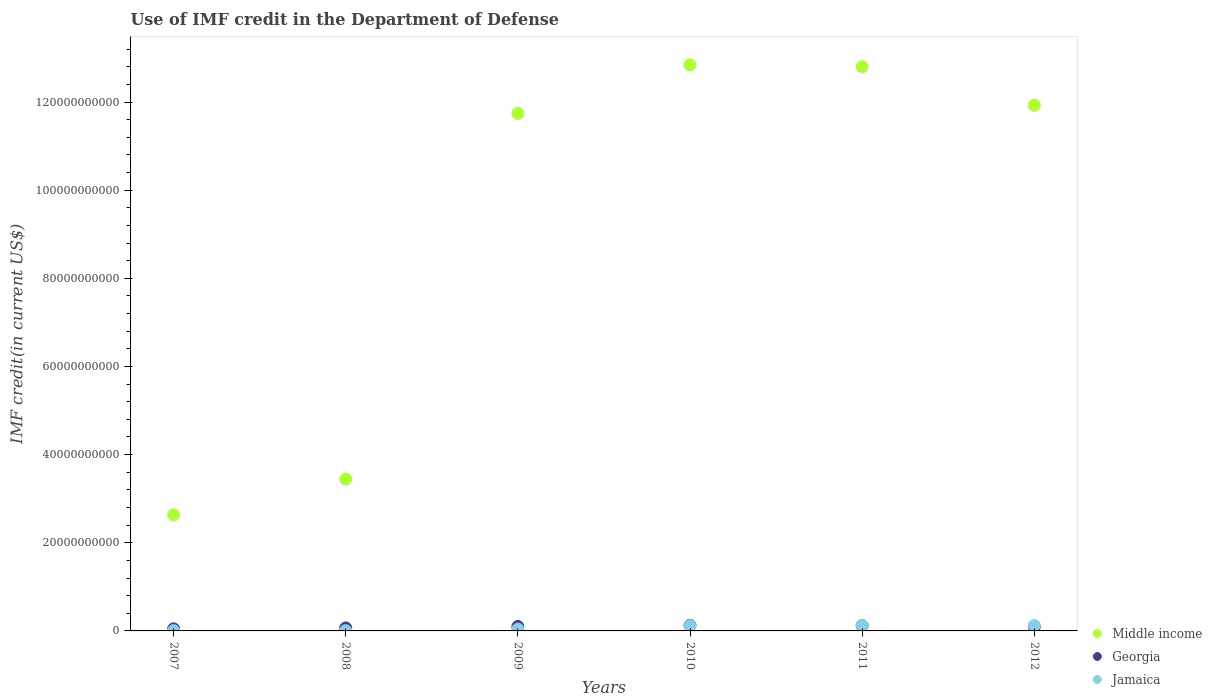What is the IMF credit in the Department of Defense in Middle income in 2009?
Provide a short and direct response. 1.17e+11. Across all years, what is the maximum IMF credit in the Department of Defense in Middle income?
Keep it short and to the point. 1.28e+11. Across all years, what is the minimum IMF credit in the Department of Defense in Jamaica?
Your answer should be very brief. 6.26e+07. In which year was the IMF credit in the Department of Defense in Middle income minimum?
Offer a very short reply. 2007. What is the total IMF credit in the Department of Defense in Jamaica in the graph?
Provide a succinct answer. 4.19e+09. What is the difference between the IMF credit in the Department of Defense in Georgia in 2010 and that in 2011?
Give a very brief answer. 6.24e+07. What is the difference between the IMF credit in the Department of Defense in Middle income in 2011 and the IMF credit in the Department of Defense in Jamaica in 2010?
Provide a succinct answer. 1.27e+11. What is the average IMF credit in the Department of Defense in Georgia per year?
Provide a short and direct response. 9.37e+08. In the year 2007, what is the difference between the IMF credit in the Department of Defense in Georgia and IMF credit in the Department of Defense in Jamaica?
Offer a terse response. 4.15e+08. In how many years, is the IMF credit in the Department of Defense in Jamaica greater than 8000000000 US$?
Your answer should be very brief. 0. What is the ratio of the IMF credit in the Department of Defense in Georgia in 2009 to that in 2012?
Provide a succinct answer. 1.05. Is the IMF credit in the Department of Defense in Georgia in 2010 less than that in 2012?
Provide a short and direct response. No. What is the difference between the highest and the second highest IMF credit in the Department of Defense in Jamaica?
Give a very brief answer. 1.32e+06. What is the difference between the highest and the lowest IMF credit in the Department of Defense in Jamaica?
Your answer should be compact. 1.17e+09. In how many years, is the IMF credit in the Department of Defense in Jamaica greater than the average IMF credit in the Department of Defense in Jamaica taken over all years?
Your answer should be compact. 3. Is the IMF credit in the Department of Defense in Jamaica strictly greater than the IMF credit in the Department of Defense in Georgia over the years?
Give a very brief answer. No. Is the IMF credit in the Department of Defense in Jamaica strictly less than the IMF credit in the Department of Defense in Middle income over the years?
Offer a very short reply. Yes. How many dotlines are there?
Provide a short and direct response. 3. Where does the legend appear in the graph?
Offer a very short reply. Bottom right. How many legend labels are there?
Give a very brief answer. 3. What is the title of the graph?
Ensure brevity in your answer.  Use of IMF credit in the Department of Defense. What is the label or title of the X-axis?
Offer a very short reply. Years. What is the label or title of the Y-axis?
Provide a short and direct response. IMF credit(in current US$). What is the IMF credit(in current US$) in Middle income in 2007?
Offer a terse response. 2.63e+1. What is the IMF credit(in current US$) of Georgia in 2007?
Keep it short and to the point. 4.79e+08. What is the IMF credit(in current US$) in Jamaica in 2007?
Provide a succinct answer. 6.42e+07. What is the IMF credit(in current US$) of Middle income in 2008?
Offer a very short reply. 3.44e+1. What is the IMF credit(in current US$) of Georgia in 2008?
Make the answer very short. 6.82e+08. What is the IMF credit(in current US$) in Jamaica in 2008?
Offer a very short reply. 6.26e+07. What is the IMF credit(in current US$) in Middle income in 2009?
Make the answer very short. 1.17e+11. What is the IMF credit(in current US$) in Georgia in 2009?
Give a very brief answer. 1.01e+09. What is the IMF credit(in current US$) in Jamaica in 2009?
Give a very brief answer. 4.10e+08. What is the IMF credit(in current US$) of Middle income in 2010?
Provide a succinct answer. 1.28e+11. What is the IMF credit(in current US$) of Georgia in 2010?
Offer a terse response. 1.27e+09. What is the IMF credit(in current US$) in Jamaica in 2010?
Your answer should be compact. 1.19e+09. What is the IMF credit(in current US$) in Middle income in 2011?
Your answer should be very brief. 1.28e+11. What is the IMF credit(in current US$) in Georgia in 2011?
Make the answer very short. 1.21e+09. What is the IMF credit(in current US$) of Jamaica in 2011?
Provide a short and direct response. 1.23e+09. What is the IMF credit(in current US$) of Middle income in 2012?
Offer a terse response. 1.19e+11. What is the IMF credit(in current US$) in Georgia in 2012?
Your response must be concise. 9.65e+08. What is the IMF credit(in current US$) of Jamaica in 2012?
Your answer should be very brief. 1.23e+09. Across all years, what is the maximum IMF credit(in current US$) of Middle income?
Your response must be concise. 1.28e+11. Across all years, what is the maximum IMF credit(in current US$) of Georgia?
Keep it short and to the point. 1.27e+09. Across all years, what is the maximum IMF credit(in current US$) in Jamaica?
Offer a terse response. 1.23e+09. Across all years, what is the minimum IMF credit(in current US$) of Middle income?
Give a very brief answer. 2.63e+1. Across all years, what is the minimum IMF credit(in current US$) of Georgia?
Make the answer very short. 4.79e+08. Across all years, what is the minimum IMF credit(in current US$) in Jamaica?
Offer a terse response. 6.26e+07. What is the total IMF credit(in current US$) of Middle income in the graph?
Make the answer very short. 5.54e+11. What is the total IMF credit(in current US$) in Georgia in the graph?
Ensure brevity in your answer.  5.62e+09. What is the total IMF credit(in current US$) of Jamaica in the graph?
Provide a short and direct response. 4.19e+09. What is the difference between the IMF credit(in current US$) of Middle income in 2007 and that in 2008?
Your response must be concise. -8.11e+09. What is the difference between the IMF credit(in current US$) of Georgia in 2007 and that in 2008?
Your answer should be very brief. -2.03e+08. What is the difference between the IMF credit(in current US$) of Jamaica in 2007 and that in 2008?
Offer a terse response. 1.62e+06. What is the difference between the IMF credit(in current US$) in Middle income in 2007 and that in 2009?
Provide a succinct answer. -9.11e+1. What is the difference between the IMF credit(in current US$) of Georgia in 2007 and that in 2009?
Give a very brief answer. -5.33e+08. What is the difference between the IMF credit(in current US$) in Jamaica in 2007 and that in 2009?
Offer a very short reply. -3.46e+08. What is the difference between the IMF credit(in current US$) of Middle income in 2007 and that in 2010?
Offer a terse response. -1.02e+11. What is the difference between the IMF credit(in current US$) of Georgia in 2007 and that in 2010?
Keep it short and to the point. -7.93e+08. What is the difference between the IMF credit(in current US$) in Jamaica in 2007 and that in 2010?
Keep it short and to the point. -1.12e+09. What is the difference between the IMF credit(in current US$) of Middle income in 2007 and that in 2011?
Make the answer very short. -1.02e+11. What is the difference between the IMF credit(in current US$) in Georgia in 2007 and that in 2011?
Ensure brevity in your answer.  -7.31e+08. What is the difference between the IMF credit(in current US$) in Jamaica in 2007 and that in 2011?
Keep it short and to the point. -1.17e+09. What is the difference between the IMF credit(in current US$) in Middle income in 2007 and that in 2012?
Offer a very short reply. -9.29e+1. What is the difference between the IMF credit(in current US$) of Georgia in 2007 and that in 2012?
Provide a short and direct response. -4.86e+08. What is the difference between the IMF credit(in current US$) in Jamaica in 2007 and that in 2012?
Offer a terse response. -1.17e+09. What is the difference between the IMF credit(in current US$) in Middle income in 2008 and that in 2009?
Offer a terse response. -8.29e+1. What is the difference between the IMF credit(in current US$) in Georgia in 2008 and that in 2009?
Provide a succinct answer. -3.30e+08. What is the difference between the IMF credit(in current US$) in Jamaica in 2008 and that in 2009?
Provide a succinct answer. -3.48e+08. What is the difference between the IMF credit(in current US$) in Middle income in 2008 and that in 2010?
Your answer should be compact. -9.40e+1. What is the difference between the IMF credit(in current US$) in Georgia in 2008 and that in 2010?
Make the answer very short. -5.90e+08. What is the difference between the IMF credit(in current US$) of Jamaica in 2008 and that in 2010?
Offer a terse response. -1.13e+09. What is the difference between the IMF credit(in current US$) of Middle income in 2008 and that in 2011?
Offer a very short reply. -9.36e+1. What is the difference between the IMF credit(in current US$) of Georgia in 2008 and that in 2011?
Your response must be concise. -5.28e+08. What is the difference between the IMF credit(in current US$) of Jamaica in 2008 and that in 2011?
Your answer should be compact. -1.17e+09. What is the difference between the IMF credit(in current US$) of Middle income in 2008 and that in 2012?
Your answer should be very brief. -8.48e+1. What is the difference between the IMF credit(in current US$) of Georgia in 2008 and that in 2012?
Provide a short and direct response. -2.83e+08. What is the difference between the IMF credit(in current US$) in Jamaica in 2008 and that in 2012?
Provide a short and direct response. -1.17e+09. What is the difference between the IMF credit(in current US$) in Middle income in 2009 and that in 2010?
Make the answer very short. -1.10e+1. What is the difference between the IMF credit(in current US$) of Georgia in 2009 and that in 2010?
Offer a terse response. -2.60e+08. What is the difference between the IMF credit(in current US$) of Jamaica in 2009 and that in 2010?
Ensure brevity in your answer.  -7.78e+08. What is the difference between the IMF credit(in current US$) of Middle income in 2009 and that in 2011?
Provide a succinct answer. -1.06e+1. What is the difference between the IMF credit(in current US$) in Georgia in 2009 and that in 2011?
Your answer should be compact. -1.98e+08. What is the difference between the IMF credit(in current US$) of Jamaica in 2009 and that in 2011?
Give a very brief answer. -8.23e+08. What is the difference between the IMF credit(in current US$) of Middle income in 2009 and that in 2012?
Give a very brief answer. -1.85e+09. What is the difference between the IMF credit(in current US$) of Georgia in 2009 and that in 2012?
Offer a very short reply. 4.68e+07. What is the difference between the IMF credit(in current US$) in Jamaica in 2009 and that in 2012?
Ensure brevity in your answer.  -8.25e+08. What is the difference between the IMF credit(in current US$) in Middle income in 2010 and that in 2011?
Your response must be concise. 4.26e+08. What is the difference between the IMF credit(in current US$) in Georgia in 2010 and that in 2011?
Your response must be concise. 6.24e+07. What is the difference between the IMF credit(in current US$) of Jamaica in 2010 and that in 2011?
Your answer should be compact. -4.53e+07. What is the difference between the IMF credit(in current US$) of Middle income in 2010 and that in 2012?
Make the answer very short. 9.18e+09. What is the difference between the IMF credit(in current US$) of Georgia in 2010 and that in 2012?
Your answer should be compact. 3.07e+08. What is the difference between the IMF credit(in current US$) in Jamaica in 2010 and that in 2012?
Provide a short and direct response. -4.66e+07. What is the difference between the IMF credit(in current US$) in Middle income in 2011 and that in 2012?
Make the answer very short. 8.76e+09. What is the difference between the IMF credit(in current US$) of Georgia in 2011 and that in 2012?
Your answer should be very brief. 2.44e+08. What is the difference between the IMF credit(in current US$) in Jamaica in 2011 and that in 2012?
Your response must be concise. -1.32e+06. What is the difference between the IMF credit(in current US$) in Middle income in 2007 and the IMF credit(in current US$) in Georgia in 2008?
Your answer should be very brief. 2.57e+1. What is the difference between the IMF credit(in current US$) of Middle income in 2007 and the IMF credit(in current US$) of Jamaica in 2008?
Your response must be concise. 2.63e+1. What is the difference between the IMF credit(in current US$) of Georgia in 2007 and the IMF credit(in current US$) of Jamaica in 2008?
Ensure brevity in your answer.  4.16e+08. What is the difference between the IMF credit(in current US$) of Middle income in 2007 and the IMF credit(in current US$) of Georgia in 2009?
Your answer should be compact. 2.53e+1. What is the difference between the IMF credit(in current US$) of Middle income in 2007 and the IMF credit(in current US$) of Jamaica in 2009?
Your answer should be very brief. 2.59e+1. What is the difference between the IMF credit(in current US$) of Georgia in 2007 and the IMF credit(in current US$) of Jamaica in 2009?
Make the answer very short. 6.88e+07. What is the difference between the IMF credit(in current US$) of Middle income in 2007 and the IMF credit(in current US$) of Georgia in 2010?
Keep it short and to the point. 2.51e+1. What is the difference between the IMF credit(in current US$) of Middle income in 2007 and the IMF credit(in current US$) of Jamaica in 2010?
Ensure brevity in your answer.  2.52e+1. What is the difference between the IMF credit(in current US$) in Georgia in 2007 and the IMF credit(in current US$) in Jamaica in 2010?
Keep it short and to the point. -7.09e+08. What is the difference between the IMF credit(in current US$) in Middle income in 2007 and the IMF credit(in current US$) in Georgia in 2011?
Make the answer very short. 2.51e+1. What is the difference between the IMF credit(in current US$) in Middle income in 2007 and the IMF credit(in current US$) in Jamaica in 2011?
Your response must be concise. 2.51e+1. What is the difference between the IMF credit(in current US$) in Georgia in 2007 and the IMF credit(in current US$) in Jamaica in 2011?
Offer a very short reply. -7.54e+08. What is the difference between the IMF credit(in current US$) of Middle income in 2007 and the IMF credit(in current US$) of Georgia in 2012?
Provide a short and direct response. 2.54e+1. What is the difference between the IMF credit(in current US$) of Middle income in 2007 and the IMF credit(in current US$) of Jamaica in 2012?
Your answer should be compact. 2.51e+1. What is the difference between the IMF credit(in current US$) in Georgia in 2007 and the IMF credit(in current US$) in Jamaica in 2012?
Your answer should be compact. -7.56e+08. What is the difference between the IMF credit(in current US$) of Middle income in 2008 and the IMF credit(in current US$) of Georgia in 2009?
Offer a very short reply. 3.34e+1. What is the difference between the IMF credit(in current US$) in Middle income in 2008 and the IMF credit(in current US$) in Jamaica in 2009?
Provide a short and direct response. 3.40e+1. What is the difference between the IMF credit(in current US$) of Georgia in 2008 and the IMF credit(in current US$) of Jamaica in 2009?
Your response must be concise. 2.72e+08. What is the difference between the IMF credit(in current US$) in Middle income in 2008 and the IMF credit(in current US$) in Georgia in 2010?
Ensure brevity in your answer.  3.32e+1. What is the difference between the IMF credit(in current US$) of Middle income in 2008 and the IMF credit(in current US$) of Jamaica in 2010?
Make the answer very short. 3.33e+1. What is the difference between the IMF credit(in current US$) of Georgia in 2008 and the IMF credit(in current US$) of Jamaica in 2010?
Offer a terse response. -5.06e+08. What is the difference between the IMF credit(in current US$) in Middle income in 2008 and the IMF credit(in current US$) in Georgia in 2011?
Give a very brief answer. 3.32e+1. What is the difference between the IMF credit(in current US$) of Middle income in 2008 and the IMF credit(in current US$) of Jamaica in 2011?
Provide a short and direct response. 3.32e+1. What is the difference between the IMF credit(in current US$) in Georgia in 2008 and the IMF credit(in current US$) in Jamaica in 2011?
Offer a terse response. -5.52e+08. What is the difference between the IMF credit(in current US$) of Middle income in 2008 and the IMF credit(in current US$) of Georgia in 2012?
Your response must be concise. 3.35e+1. What is the difference between the IMF credit(in current US$) of Middle income in 2008 and the IMF credit(in current US$) of Jamaica in 2012?
Make the answer very short. 3.32e+1. What is the difference between the IMF credit(in current US$) in Georgia in 2008 and the IMF credit(in current US$) in Jamaica in 2012?
Your response must be concise. -5.53e+08. What is the difference between the IMF credit(in current US$) in Middle income in 2009 and the IMF credit(in current US$) in Georgia in 2010?
Your response must be concise. 1.16e+11. What is the difference between the IMF credit(in current US$) of Middle income in 2009 and the IMF credit(in current US$) of Jamaica in 2010?
Ensure brevity in your answer.  1.16e+11. What is the difference between the IMF credit(in current US$) in Georgia in 2009 and the IMF credit(in current US$) in Jamaica in 2010?
Provide a succinct answer. -1.76e+08. What is the difference between the IMF credit(in current US$) of Middle income in 2009 and the IMF credit(in current US$) of Georgia in 2011?
Your answer should be compact. 1.16e+11. What is the difference between the IMF credit(in current US$) in Middle income in 2009 and the IMF credit(in current US$) in Jamaica in 2011?
Make the answer very short. 1.16e+11. What is the difference between the IMF credit(in current US$) of Georgia in 2009 and the IMF credit(in current US$) of Jamaica in 2011?
Give a very brief answer. -2.21e+08. What is the difference between the IMF credit(in current US$) of Middle income in 2009 and the IMF credit(in current US$) of Georgia in 2012?
Make the answer very short. 1.16e+11. What is the difference between the IMF credit(in current US$) of Middle income in 2009 and the IMF credit(in current US$) of Jamaica in 2012?
Make the answer very short. 1.16e+11. What is the difference between the IMF credit(in current US$) in Georgia in 2009 and the IMF credit(in current US$) in Jamaica in 2012?
Your answer should be compact. -2.23e+08. What is the difference between the IMF credit(in current US$) in Middle income in 2010 and the IMF credit(in current US$) in Georgia in 2011?
Provide a short and direct response. 1.27e+11. What is the difference between the IMF credit(in current US$) in Middle income in 2010 and the IMF credit(in current US$) in Jamaica in 2011?
Offer a terse response. 1.27e+11. What is the difference between the IMF credit(in current US$) in Georgia in 2010 and the IMF credit(in current US$) in Jamaica in 2011?
Offer a terse response. 3.87e+07. What is the difference between the IMF credit(in current US$) of Middle income in 2010 and the IMF credit(in current US$) of Georgia in 2012?
Make the answer very short. 1.27e+11. What is the difference between the IMF credit(in current US$) in Middle income in 2010 and the IMF credit(in current US$) in Jamaica in 2012?
Offer a terse response. 1.27e+11. What is the difference between the IMF credit(in current US$) in Georgia in 2010 and the IMF credit(in current US$) in Jamaica in 2012?
Make the answer very short. 3.73e+07. What is the difference between the IMF credit(in current US$) in Middle income in 2011 and the IMF credit(in current US$) in Georgia in 2012?
Offer a very short reply. 1.27e+11. What is the difference between the IMF credit(in current US$) of Middle income in 2011 and the IMF credit(in current US$) of Jamaica in 2012?
Make the answer very short. 1.27e+11. What is the difference between the IMF credit(in current US$) of Georgia in 2011 and the IMF credit(in current US$) of Jamaica in 2012?
Your answer should be very brief. -2.51e+07. What is the average IMF credit(in current US$) of Middle income per year?
Provide a succinct answer. 9.23e+1. What is the average IMF credit(in current US$) in Georgia per year?
Offer a terse response. 9.37e+08. What is the average IMF credit(in current US$) in Jamaica per year?
Give a very brief answer. 6.99e+08. In the year 2007, what is the difference between the IMF credit(in current US$) of Middle income and IMF credit(in current US$) of Georgia?
Your answer should be compact. 2.59e+1. In the year 2007, what is the difference between the IMF credit(in current US$) in Middle income and IMF credit(in current US$) in Jamaica?
Provide a short and direct response. 2.63e+1. In the year 2007, what is the difference between the IMF credit(in current US$) in Georgia and IMF credit(in current US$) in Jamaica?
Make the answer very short. 4.15e+08. In the year 2008, what is the difference between the IMF credit(in current US$) in Middle income and IMF credit(in current US$) in Georgia?
Ensure brevity in your answer.  3.38e+1. In the year 2008, what is the difference between the IMF credit(in current US$) in Middle income and IMF credit(in current US$) in Jamaica?
Give a very brief answer. 3.44e+1. In the year 2008, what is the difference between the IMF credit(in current US$) in Georgia and IMF credit(in current US$) in Jamaica?
Keep it short and to the point. 6.19e+08. In the year 2009, what is the difference between the IMF credit(in current US$) in Middle income and IMF credit(in current US$) in Georgia?
Your answer should be very brief. 1.16e+11. In the year 2009, what is the difference between the IMF credit(in current US$) in Middle income and IMF credit(in current US$) in Jamaica?
Your answer should be compact. 1.17e+11. In the year 2009, what is the difference between the IMF credit(in current US$) in Georgia and IMF credit(in current US$) in Jamaica?
Offer a very short reply. 6.02e+08. In the year 2010, what is the difference between the IMF credit(in current US$) in Middle income and IMF credit(in current US$) in Georgia?
Provide a short and direct response. 1.27e+11. In the year 2010, what is the difference between the IMF credit(in current US$) of Middle income and IMF credit(in current US$) of Jamaica?
Keep it short and to the point. 1.27e+11. In the year 2010, what is the difference between the IMF credit(in current US$) of Georgia and IMF credit(in current US$) of Jamaica?
Give a very brief answer. 8.40e+07. In the year 2011, what is the difference between the IMF credit(in current US$) in Middle income and IMF credit(in current US$) in Georgia?
Your response must be concise. 1.27e+11. In the year 2011, what is the difference between the IMF credit(in current US$) in Middle income and IMF credit(in current US$) in Jamaica?
Your response must be concise. 1.27e+11. In the year 2011, what is the difference between the IMF credit(in current US$) in Georgia and IMF credit(in current US$) in Jamaica?
Your response must be concise. -2.38e+07. In the year 2012, what is the difference between the IMF credit(in current US$) of Middle income and IMF credit(in current US$) of Georgia?
Provide a succinct answer. 1.18e+11. In the year 2012, what is the difference between the IMF credit(in current US$) of Middle income and IMF credit(in current US$) of Jamaica?
Keep it short and to the point. 1.18e+11. In the year 2012, what is the difference between the IMF credit(in current US$) in Georgia and IMF credit(in current US$) in Jamaica?
Provide a short and direct response. -2.70e+08. What is the ratio of the IMF credit(in current US$) in Middle income in 2007 to that in 2008?
Make the answer very short. 0.76. What is the ratio of the IMF credit(in current US$) of Georgia in 2007 to that in 2008?
Give a very brief answer. 0.7. What is the ratio of the IMF credit(in current US$) of Jamaica in 2007 to that in 2008?
Ensure brevity in your answer.  1.03. What is the ratio of the IMF credit(in current US$) in Middle income in 2007 to that in 2009?
Keep it short and to the point. 0.22. What is the ratio of the IMF credit(in current US$) in Georgia in 2007 to that in 2009?
Keep it short and to the point. 0.47. What is the ratio of the IMF credit(in current US$) in Jamaica in 2007 to that in 2009?
Keep it short and to the point. 0.16. What is the ratio of the IMF credit(in current US$) in Middle income in 2007 to that in 2010?
Offer a very short reply. 0.21. What is the ratio of the IMF credit(in current US$) in Georgia in 2007 to that in 2010?
Make the answer very short. 0.38. What is the ratio of the IMF credit(in current US$) in Jamaica in 2007 to that in 2010?
Ensure brevity in your answer.  0.05. What is the ratio of the IMF credit(in current US$) in Middle income in 2007 to that in 2011?
Ensure brevity in your answer.  0.21. What is the ratio of the IMF credit(in current US$) in Georgia in 2007 to that in 2011?
Give a very brief answer. 0.4. What is the ratio of the IMF credit(in current US$) of Jamaica in 2007 to that in 2011?
Provide a succinct answer. 0.05. What is the ratio of the IMF credit(in current US$) of Middle income in 2007 to that in 2012?
Your answer should be compact. 0.22. What is the ratio of the IMF credit(in current US$) of Georgia in 2007 to that in 2012?
Give a very brief answer. 0.5. What is the ratio of the IMF credit(in current US$) in Jamaica in 2007 to that in 2012?
Offer a very short reply. 0.05. What is the ratio of the IMF credit(in current US$) of Middle income in 2008 to that in 2009?
Your answer should be compact. 0.29. What is the ratio of the IMF credit(in current US$) of Georgia in 2008 to that in 2009?
Offer a very short reply. 0.67. What is the ratio of the IMF credit(in current US$) of Jamaica in 2008 to that in 2009?
Give a very brief answer. 0.15. What is the ratio of the IMF credit(in current US$) in Middle income in 2008 to that in 2010?
Keep it short and to the point. 0.27. What is the ratio of the IMF credit(in current US$) of Georgia in 2008 to that in 2010?
Make the answer very short. 0.54. What is the ratio of the IMF credit(in current US$) in Jamaica in 2008 to that in 2010?
Offer a very short reply. 0.05. What is the ratio of the IMF credit(in current US$) in Middle income in 2008 to that in 2011?
Give a very brief answer. 0.27. What is the ratio of the IMF credit(in current US$) in Georgia in 2008 to that in 2011?
Your answer should be very brief. 0.56. What is the ratio of the IMF credit(in current US$) of Jamaica in 2008 to that in 2011?
Your answer should be compact. 0.05. What is the ratio of the IMF credit(in current US$) in Middle income in 2008 to that in 2012?
Give a very brief answer. 0.29. What is the ratio of the IMF credit(in current US$) of Georgia in 2008 to that in 2012?
Your answer should be compact. 0.71. What is the ratio of the IMF credit(in current US$) in Jamaica in 2008 to that in 2012?
Keep it short and to the point. 0.05. What is the ratio of the IMF credit(in current US$) of Middle income in 2009 to that in 2010?
Offer a very short reply. 0.91. What is the ratio of the IMF credit(in current US$) of Georgia in 2009 to that in 2010?
Provide a succinct answer. 0.8. What is the ratio of the IMF credit(in current US$) in Jamaica in 2009 to that in 2010?
Give a very brief answer. 0.35. What is the ratio of the IMF credit(in current US$) in Middle income in 2009 to that in 2011?
Offer a very short reply. 0.92. What is the ratio of the IMF credit(in current US$) in Georgia in 2009 to that in 2011?
Ensure brevity in your answer.  0.84. What is the ratio of the IMF credit(in current US$) of Jamaica in 2009 to that in 2011?
Ensure brevity in your answer.  0.33. What is the ratio of the IMF credit(in current US$) in Middle income in 2009 to that in 2012?
Provide a succinct answer. 0.98. What is the ratio of the IMF credit(in current US$) of Georgia in 2009 to that in 2012?
Offer a terse response. 1.05. What is the ratio of the IMF credit(in current US$) of Jamaica in 2009 to that in 2012?
Your answer should be very brief. 0.33. What is the ratio of the IMF credit(in current US$) of Middle income in 2010 to that in 2011?
Make the answer very short. 1. What is the ratio of the IMF credit(in current US$) in Georgia in 2010 to that in 2011?
Provide a succinct answer. 1.05. What is the ratio of the IMF credit(in current US$) in Jamaica in 2010 to that in 2011?
Give a very brief answer. 0.96. What is the ratio of the IMF credit(in current US$) of Middle income in 2010 to that in 2012?
Offer a terse response. 1.08. What is the ratio of the IMF credit(in current US$) in Georgia in 2010 to that in 2012?
Offer a terse response. 1.32. What is the ratio of the IMF credit(in current US$) in Jamaica in 2010 to that in 2012?
Offer a terse response. 0.96. What is the ratio of the IMF credit(in current US$) in Middle income in 2011 to that in 2012?
Provide a short and direct response. 1.07. What is the ratio of the IMF credit(in current US$) in Georgia in 2011 to that in 2012?
Ensure brevity in your answer.  1.25. What is the difference between the highest and the second highest IMF credit(in current US$) in Middle income?
Your answer should be compact. 4.26e+08. What is the difference between the highest and the second highest IMF credit(in current US$) in Georgia?
Make the answer very short. 6.24e+07. What is the difference between the highest and the second highest IMF credit(in current US$) in Jamaica?
Provide a short and direct response. 1.32e+06. What is the difference between the highest and the lowest IMF credit(in current US$) of Middle income?
Ensure brevity in your answer.  1.02e+11. What is the difference between the highest and the lowest IMF credit(in current US$) in Georgia?
Your response must be concise. 7.93e+08. What is the difference between the highest and the lowest IMF credit(in current US$) in Jamaica?
Make the answer very short. 1.17e+09. 